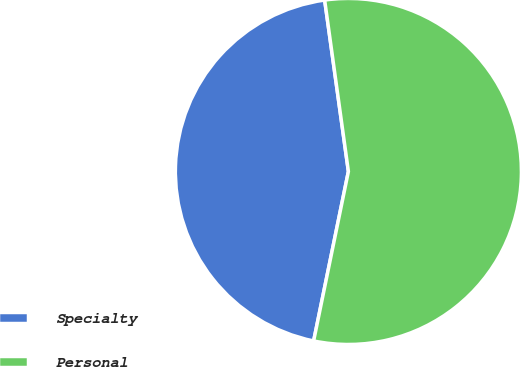Convert chart. <chart><loc_0><loc_0><loc_500><loc_500><pie_chart><fcel>Specialty<fcel>Personal<nl><fcel>44.59%<fcel>55.41%<nl></chart> 